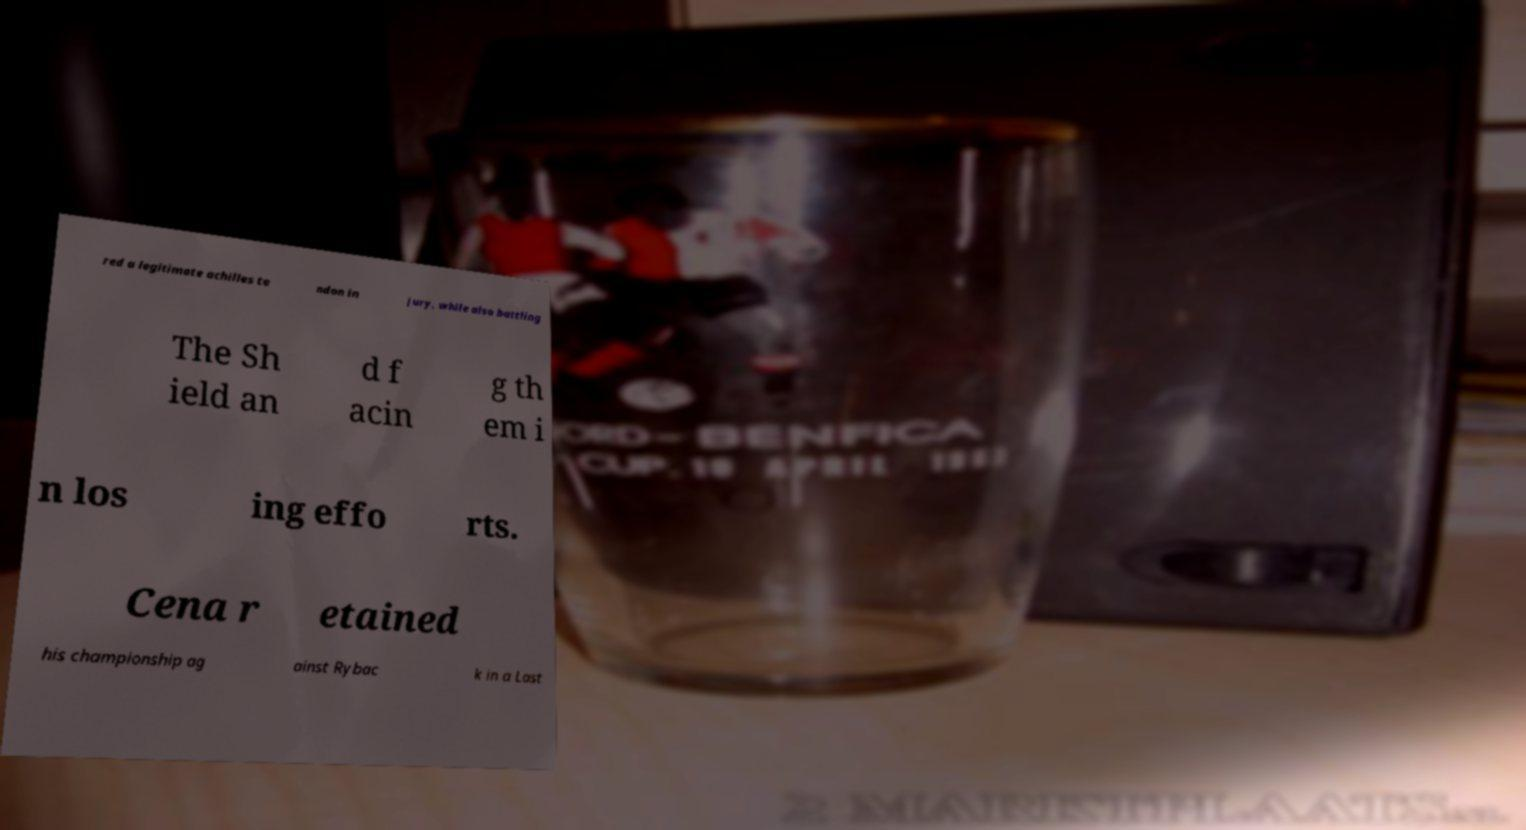Can you accurately transcribe the text from the provided image for me? red a legitimate achilles te ndon in jury, while also battling The Sh ield an d f acin g th em i n los ing effo rts. Cena r etained his championship ag ainst Rybac k in a Last 